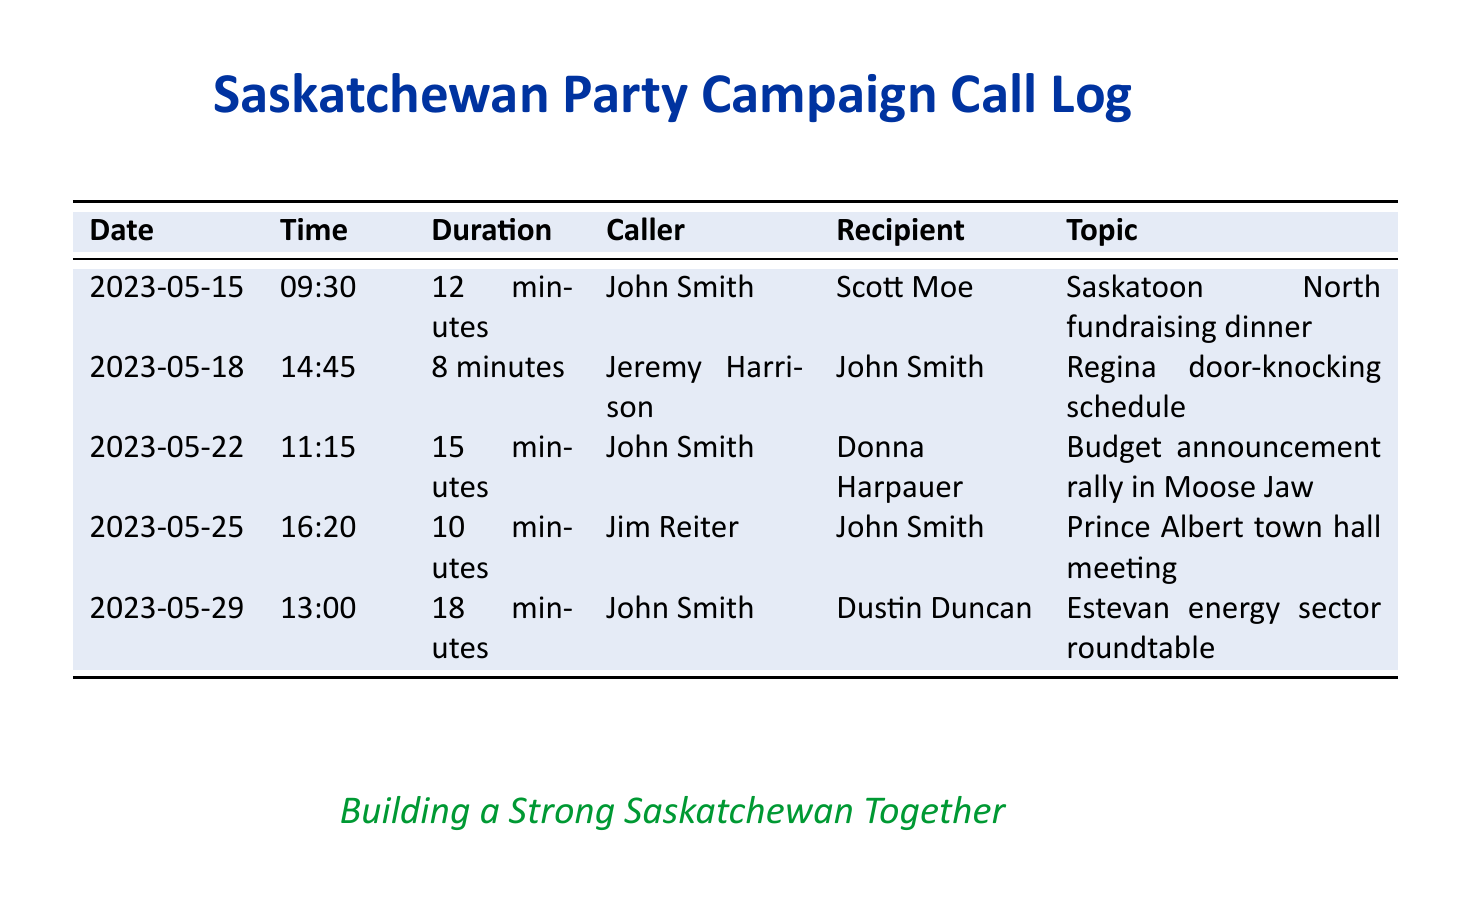What is the date of the fundraising dinner? The date of the fundraising dinner is found in the entry for that event in the call log.
Answer: 2023-05-15 Who called to discuss the Regina door-knocking schedule? The caller's name for the Regina door-knocking schedule is noted in the corresponding entry of the call log.
Answer: Jeremy Harrison What was the duration of the call regarding the budget announcement rally? The duration can be extracted directly from the entry related to the budget announcement rally meeting.
Answer: 15 minutes Which representative was involved in the call about the Estevan energy sector roundtable? The recipient of the call regarding the Estevan energy sector roundtable is specified in the relevant entry.
Answer: Dustin Duncan How many minutes did the call about the Prince Albert town hall meeting last? The duration of the call about the Prince Albert town hall meeting can be found in the specific entry for that call.
Answer: 10 minutes Who was the caller for the call about the Saskatoon North fundraising dinner? The name of the caller for the Saskatoon North fundraising dinner is provided in that call log entry.
Answer: John Smith Which location is associated with the budget announcement rally? The location is indicated in the context of the budget announcement rally mentioned in the call log.
Answer: Moose Jaw How many calls were made in total according to the document? The total number of calls can be derived by counting each distinct entry in the call log.
Answer: 5 